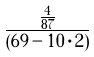<formula> <loc_0><loc_0><loc_500><loc_500>\frac { \frac { 4 } { 8 7 } } { ( 6 9 - 1 0 \cdot 2 ) }</formula> 